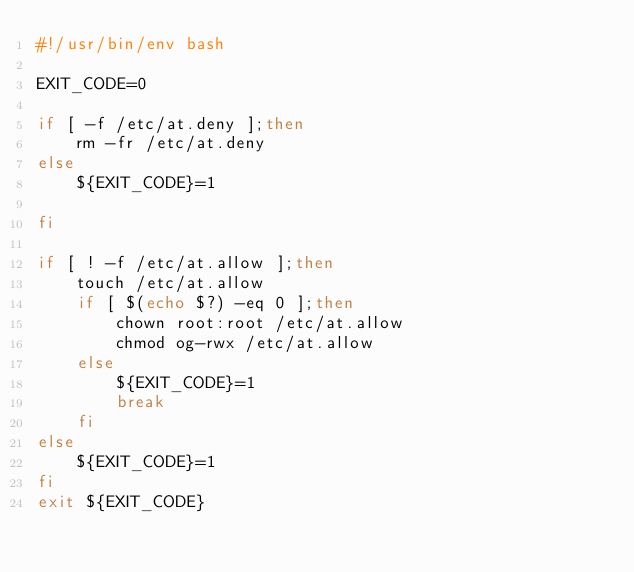<code> <loc_0><loc_0><loc_500><loc_500><_Bash_>#!/usr/bin/env bash

EXIT_CODE=0

if [ -f /etc/at.deny ];then
    rm -fr /etc/at.deny
else
    ${EXIT_CODE}=1

fi

if [ ! -f /etc/at.allow ];then
    touch /etc/at.allow
    if [ $(echo $?) -eq 0 ];then
        chown root:root /etc/at.allow
        chmod og-rwx /etc/at.allow
    else
        ${EXIT_CODE}=1
        break
    fi
else
    ${EXIT_CODE}=1
fi
exit ${EXIT_CODE}
</code> 